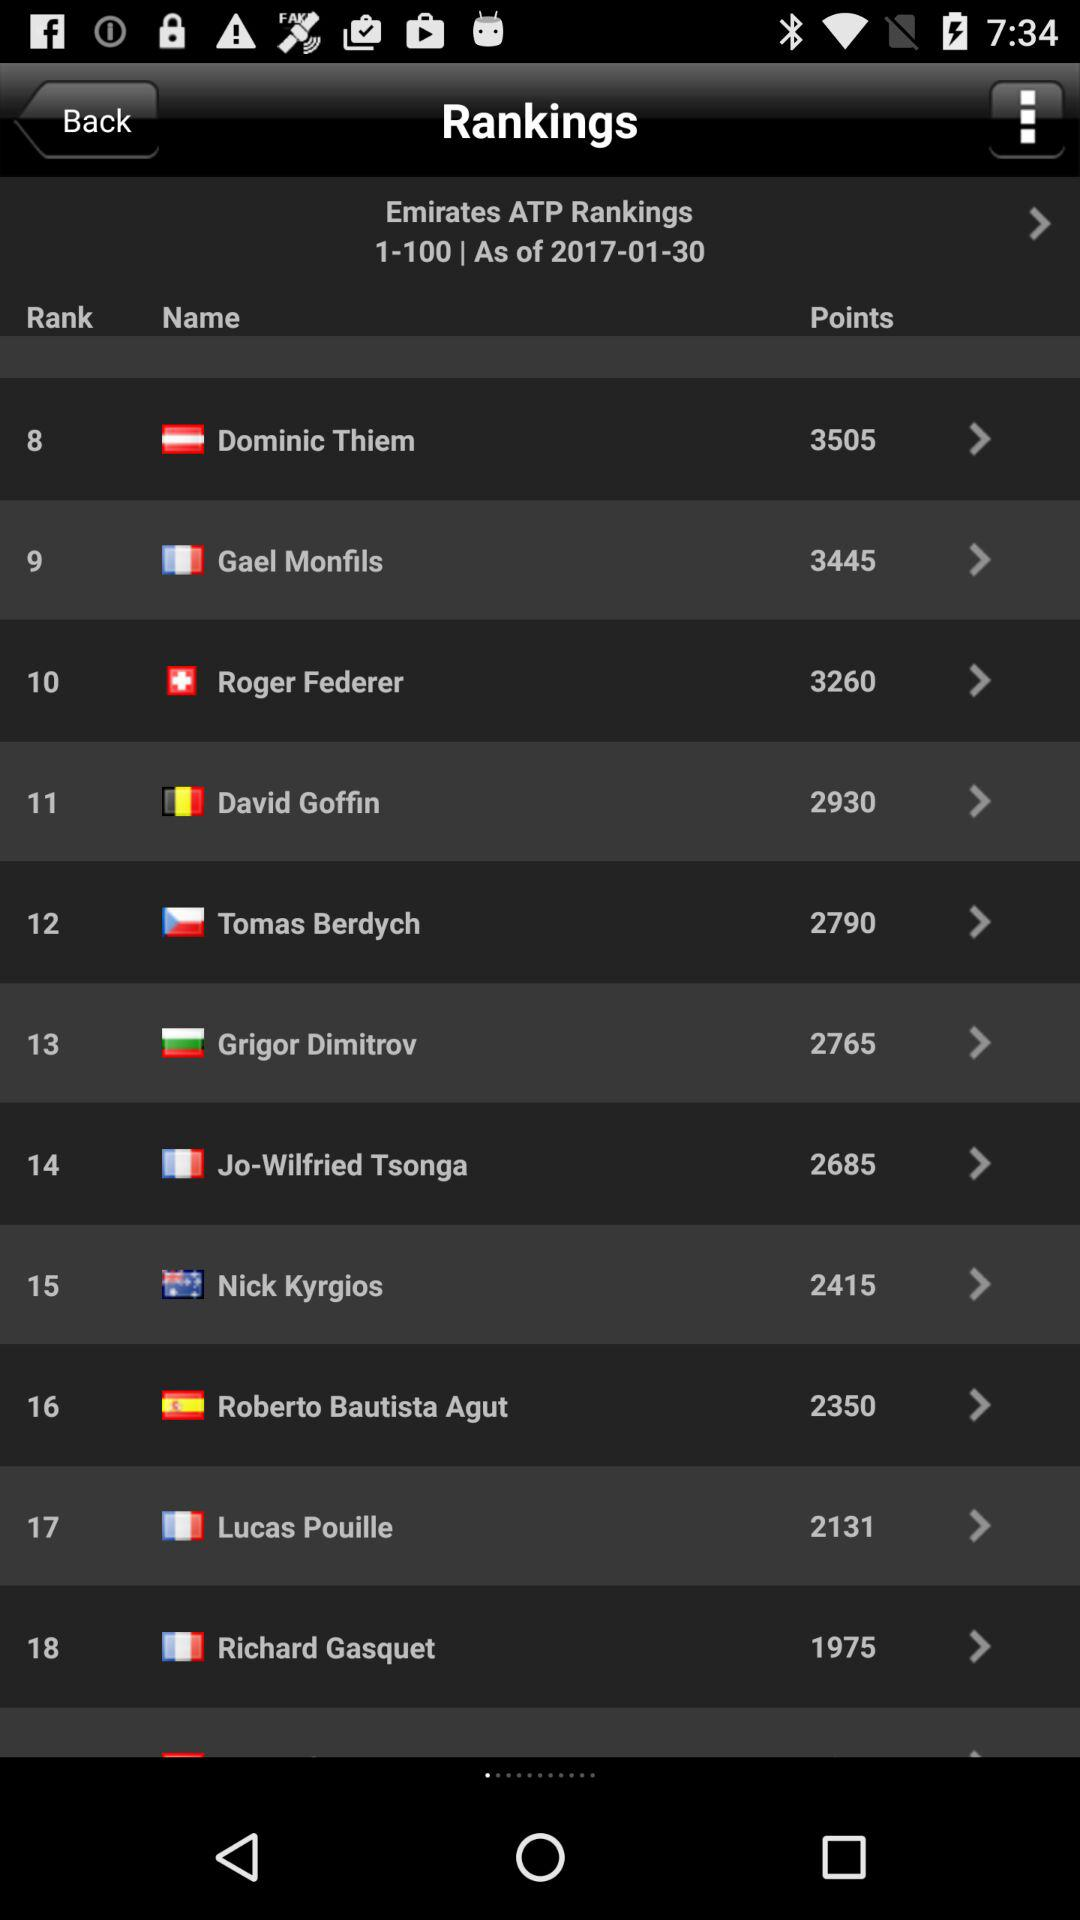What date is displayed on the screen? The date displayed on the screen is January 1, 2017. 